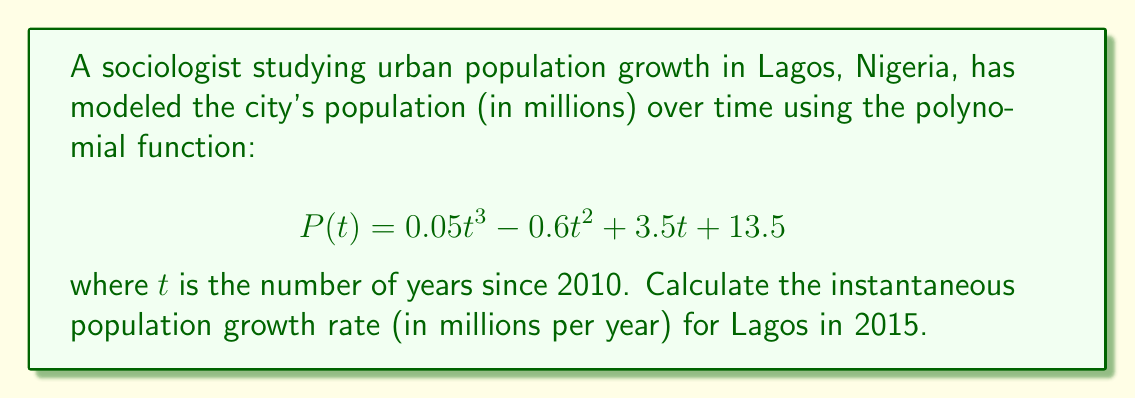Solve this math problem. To solve this problem, we need to follow these steps:

1) The instantaneous population growth rate at any given time is represented by the derivative of the population function $P(t)$.

2) Let's find the derivative of $P(t)$:
   $$P'(t) = 0.15t^2 - 1.2t + 3.5$$

3) We need to calculate the growth rate for 2015, which is 5 years after 2010. So, we need to evaluate $P'(5)$.

4) Substitute $t=5$ into the derivative function:
   $$P'(5) = 0.15(5^2) - 1.2(5) + 3.5$$

5) Simplify:
   $$P'(5) = 0.15(25) - 6 + 3.5$$
   $$P'(5) = 3.75 - 6 + 3.5$$
   $$P'(5) = 1.25$$

6) Therefore, the instantaneous population growth rate in 2015 is 1.25 million people per year.
Answer: 1.25 million people per year 